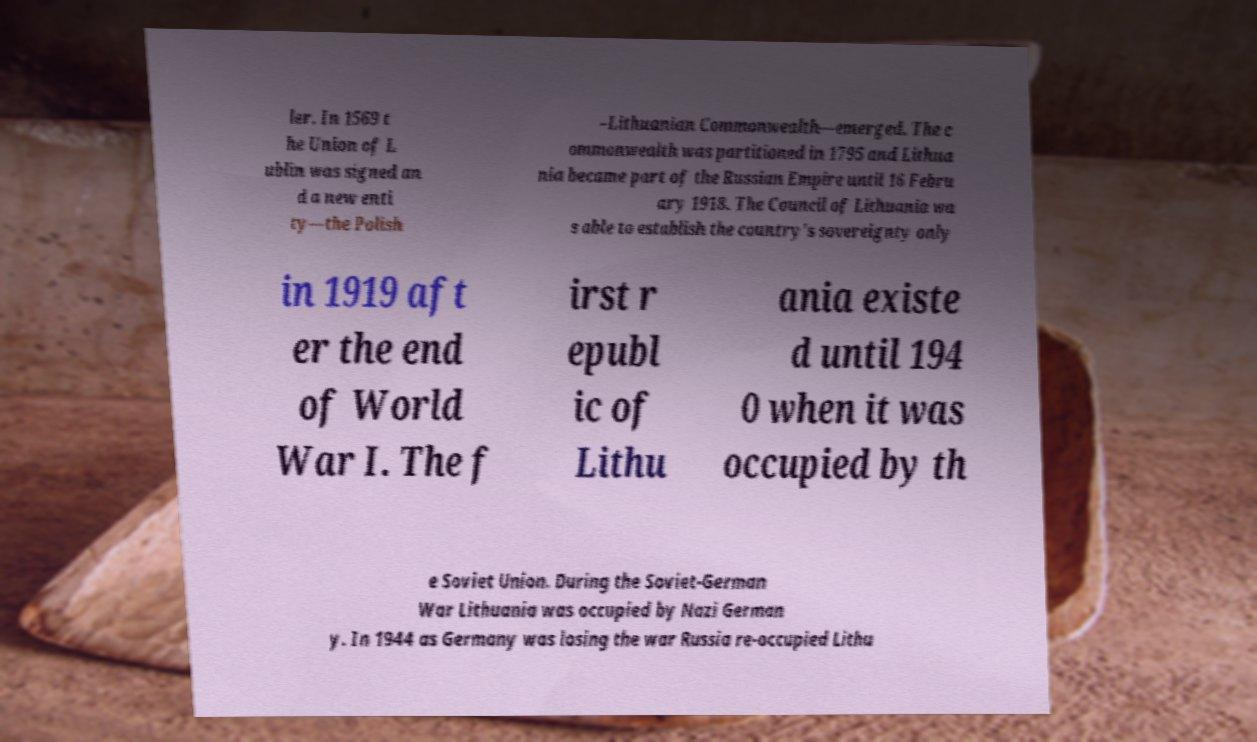Please read and relay the text visible in this image. What does it say? ler. In 1569 t he Union of L ublin was signed an d a new enti ty—the Polish –Lithuanian Commonwealth—emerged. The c ommonwealth was partitioned in 1795 and Lithua nia became part of the Russian Empire until 16 Febru ary 1918. The Council of Lithuania wa s able to establish the country's sovereignty only in 1919 aft er the end of World War I. The f irst r epubl ic of Lithu ania existe d until 194 0 when it was occupied by th e Soviet Union. During the Soviet-German War Lithuania was occupied by Nazi German y. In 1944 as Germany was losing the war Russia re-occupied Lithu 